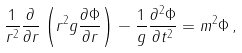Convert formula to latex. <formula><loc_0><loc_0><loc_500><loc_500>\frac { 1 } { r ^ { 2 } } \frac { \partial } { \partial r } \left ( r ^ { 2 } g \frac { \partial \Phi } { \partial r } \right ) - \frac { 1 } { g } \frac { \partial ^ { 2 } \Phi } { \partial t ^ { 2 } } = m ^ { 2 } \Phi \, ,</formula> 